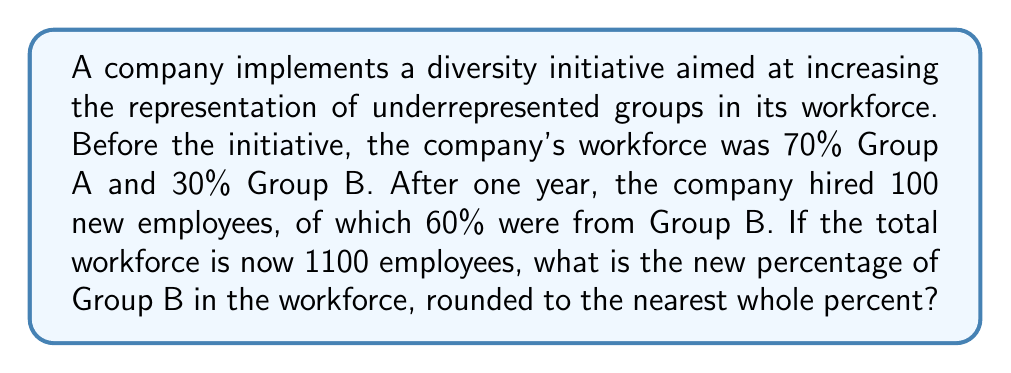Provide a solution to this math problem. Let's approach this step-by-step:

1) First, let's calculate the initial number of employees:
   Total employees after hiring = 1100
   New hires = 100
   Initial employees = 1100 - 100 = 1000

2) Now, let's calculate the initial number of employees in each group:
   Group A: 70% of 1000 = 0.7 × 1000 = 700
   Group B: 30% of 1000 = 0.3 × 1000 = 300

3) Calculate the number of new hires for each group:
   New Group B hires: 60% of 100 = 0.6 × 100 = 60
   New Group A hires: 40% of 100 = 0.4 × 100 = 40

4) Calculate the new total for each group:
   New Group A total: 700 + 40 = 740
   New Group B total: 300 + 60 = 360

5) Calculate the new percentage of Group B:
   $$\text{New Group B Percentage} = \frac{\text{New Group B Total}}{\text{Total Employees}} \times 100\%$$
   $$= \frac{360}{1100} \times 100\% \approx 32.73\%$$

6) Rounding to the nearest whole percent:
   32.73% rounds to 33%
Answer: 33% 